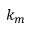<formula> <loc_0><loc_0><loc_500><loc_500>k _ { m }</formula> 